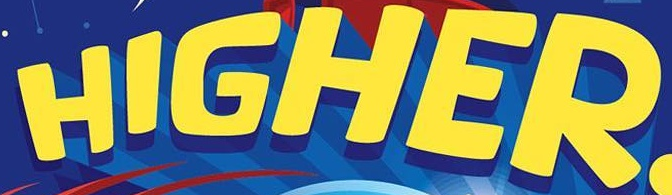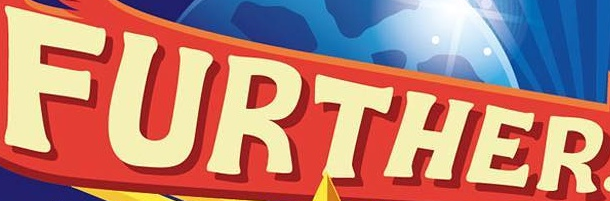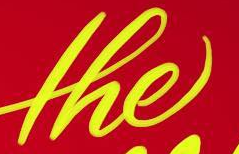What words can you see in these images in sequence, separated by a semicolon? HIGHER; FURTHER; the 